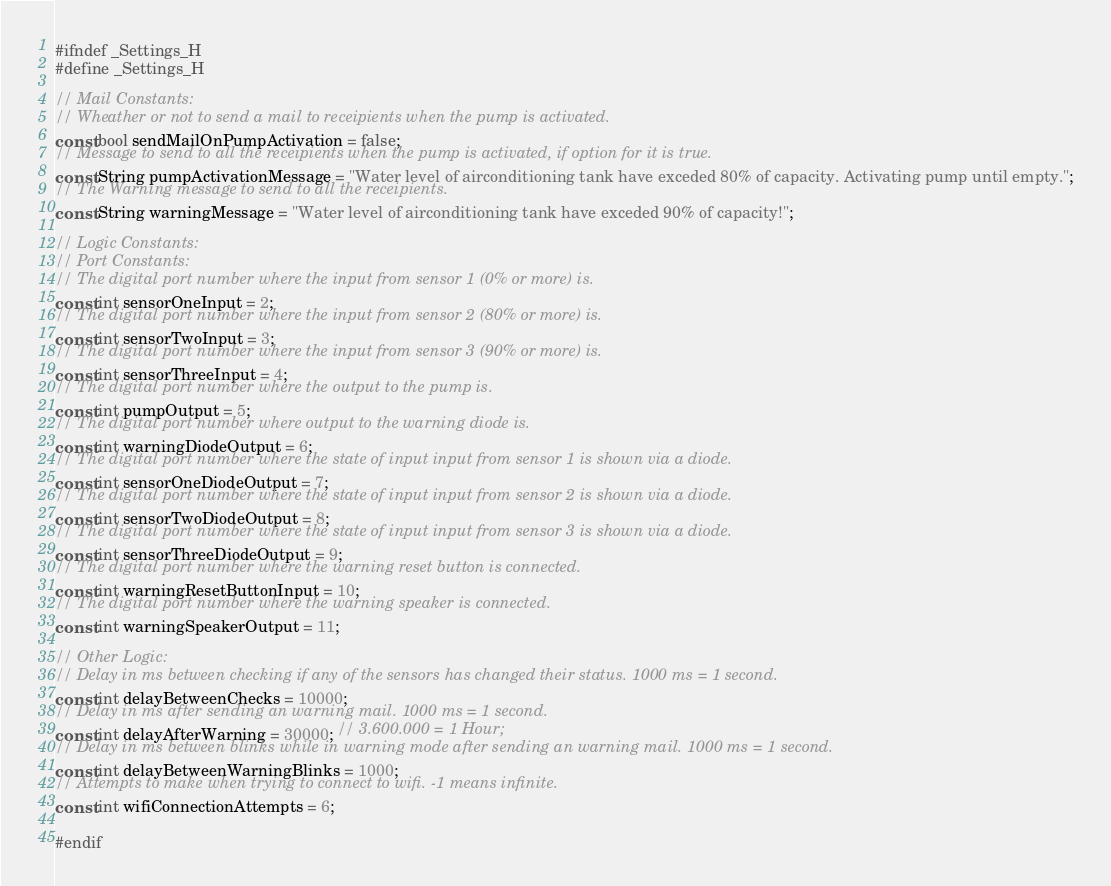Convert code to text. <code><loc_0><loc_0><loc_500><loc_500><_C_>#ifndef _Settings_H
#define _Settings_H

// Mail Constants:
// Wheather or not to send a mail to receipients when the pump is activated.
const bool sendMailOnPumpActivation = false;
// Message to send to all the receipients when the pump is activated, if option for it is true.
const String pumpActivationMessage = "Water level of airconditioning tank have exceded 80% of capacity. Activating pump until empty.";
// The Warning message to send to all the receipients.
const String warningMessage = "Water level of airconditioning tank have exceded 90% of capacity!";

// Logic Constants:
// Port Constants:
// The digital port number where the input from sensor 1 (0% or more) is.
const int sensorOneInput = 2;
// The digital port number where the input from sensor 2 (80% or more) is.
const int sensorTwoInput = 3;
// The digital port number where the input from sensor 3 (90% or more) is.
const int sensorThreeInput = 4;
// The digital port number where the output to the pump is.
const int pumpOutput = 5;
// The digital port number where output to the warning diode is.
const int warningDiodeOutput = 6;
// The digital port number where the state of input input from sensor 1 is shown via a diode.
const int sensorOneDiodeOutput = 7;
// The digital port number where the state of input input from sensor 2 is shown via a diode.
const int sensorTwoDiodeOutput = 8;
// The digital port number where the state of input input from sensor 3 is shown via a diode.
const int sensorThreeDiodeOutput = 9;
// The digital port number where the warning reset button is connected.
const int warningResetButtonInput = 10;
// The digital port number where the warning speaker is connected.
const int warningSpeakerOutput = 11;

// Other Logic:
// Delay in ms between checking if any of the sensors has changed their status. 1000 ms = 1 second.
const int delayBetweenChecks = 10000;
// Delay in ms after sending an warning mail. 1000 ms = 1 second.
const int delayAfterWarning = 30000; // 3.600.000 = 1 Hour;
// Delay in ms between blinks while in warning mode after sending an warning mail. 1000 ms = 1 second.
const int delayBetweenWarningBlinks = 1000;
// Attempts to make when trying to connect to wifi. -1 means infinite.
const int wifiConnectionAttempts = 6;

#endif
</code> 